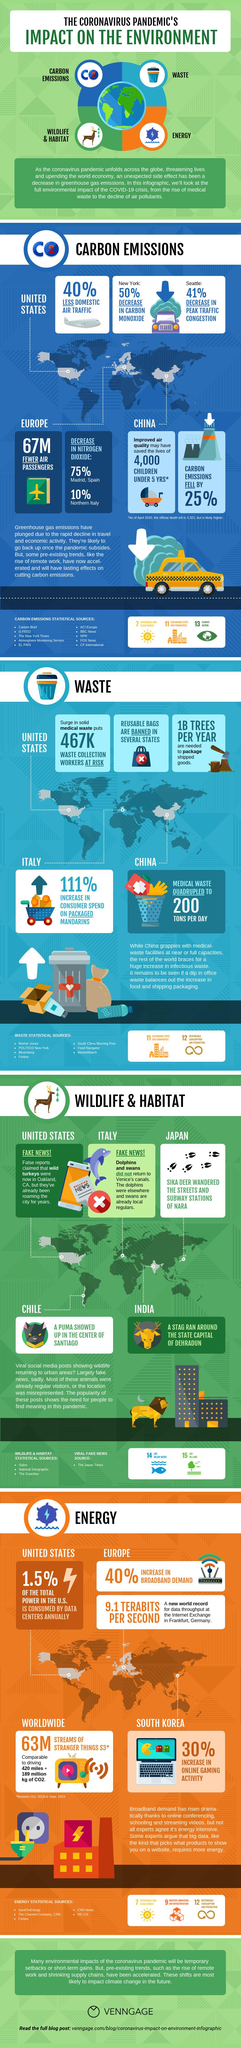List a handful of essential elements in this visual. During the COVID-19 pandemic, office waste was found to have significantly decreased in amount. The new world record for data throughput was set at an internet exchange in Frankfurt, Germany. The increase in online gaming activity in South Korea during the COVID-19 pandemic was 30%. According to recent estimates, the data centers in the United States consume approximately 1.5% of the nation's annual electricity usage. The reduction in nitrogen dioxide levels in Northern Italy during the COVID-19 pandemic was approximately 10%. 